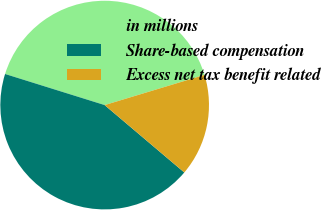<chart> <loc_0><loc_0><loc_500><loc_500><pie_chart><fcel>in millions<fcel>Share-based compensation<fcel>Excess net tax benefit related<nl><fcel>40.51%<fcel>43.64%<fcel>15.85%<nl></chart> 